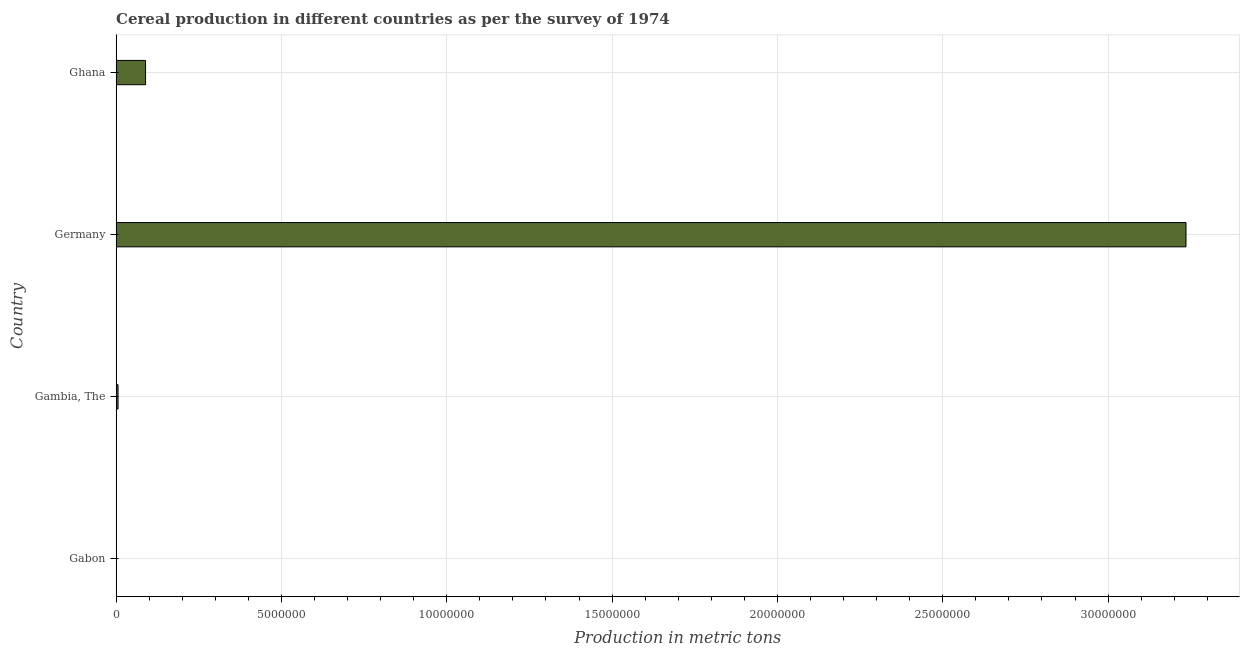What is the title of the graph?
Ensure brevity in your answer.  Cereal production in different countries as per the survey of 1974. What is the label or title of the X-axis?
Make the answer very short. Production in metric tons. What is the label or title of the Y-axis?
Provide a short and direct response. Country. What is the cereal production in Gabon?
Provide a succinct answer. 8368. Across all countries, what is the maximum cereal production?
Offer a terse response. 3.24e+07. Across all countries, what is the minimum cereal production?
Offer a terse response. 8368. In which country was the cereal production minimum?
Offer a very short reply. Gabon. What is the sum of the cereal production?
Provide a short and direct response. 3.33e+07. What is the difference between the cereal production in Gabon and Germany?
Provide a short and direct response. -3.23e+07. What is the average cereal production per country?
Offer a very short reply. 8.33e+06. What is the median cereal production?
Provide a short and direct response. 4.74e+05. In how many countries, is the cereal production greater than 5000000 metric tons?
Offer a very short reply. 1. What is the ratio of the cereal production in Gambia, The to that in Germany?
Offer a very short reply. 0. Is the cereal production in Gabon less than that in Germany?
Keep it short and to the point. Yes. What is the difference between the highest and the second highest cereal production?
Offer a very short reply. 3.15e+07. Is the sum of the cereal production in Gambia, The and Germany greater than the maximum cereal production across all countries?
Provide a succinct answer. Yes. What is the difference between the highest and the lowest cereal production?
Keep it short and to the point. 3.23e+07. In how many countries, is the cereal production greater than the average cereal production taken over all countries?
Offer a very short reply. 1. How many bars are there?
Make the answer very short. 4. How many countries are there in the graph?
Your response must be concise. 4. What is the difference between two consecutive major ticks on the X-axis?
Your answer should be very brief. 5.00e+06. What is the Production in metric tons of Gabon?
Your answer should be compact. 8368. What is the Production in metric tons in Gambia, The?
Your answer should be very brief. 5.82e+04. What is the Production in metric tons of Germany?
Your answer should be compact. 3.24e+07. What is the Production in metric tons of Ghana?
Keep it short and to the point. 8.90e+05. What is the difference between the Production in metric tons in Gabon and Gambia, The?
Ensure brevity in your answer.  -4.98e+04. What is the difference between the Production in metric tons in Gabon and Germany?
Offer a terse response. -3.23e+07. What is the difference between the Production in metric tons in Gabon and Ghana?
Offer a very short reply. -8.82e+05. What is the difference between the Production in metric tons in Gambia, The and Germany?
Offer a very short reply. -3.23e+07. What is the difference between the Production in metric tons in Gambia, The and Ghana?
Give a very brief answer. -8.32e+05. What is the difference between the Production in metric tons in Germany and Ghana?
Offer a terse response. 3.15e+07. What is the ratio of the Production in metric tons in Gabon to that in Gambia, The?
Keep it short and to the point. 0.14. What is the ratio of the Production in metric tons in Gabon to that in Ghana?
Keep it short and to the point. 0.01. What is the ratio of the Production in metric tons in Gambia, The to that in Germany?
Offer a very short reply. 0. What is the ratio of the Production in metric tons in Gambia, The to that in Ghana?
Ensure brevity in your answer.  0.07. What is the ratio of the Production in metric tons in Germany to that in Ghana?
Your answer should be compact. 36.35. 